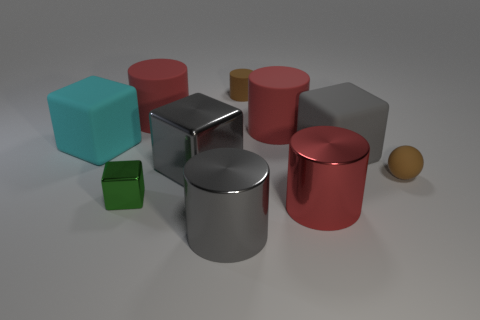How many objects are the same shape? Within the image, there are several objects sharing identical shapes. For instance, there are two large cylinders and numerous cubes, each pair matching in shape.  Can you tell the relative sizes of these objects? The objects vary in size, with some shapes like the cubes being present in at least two distinct sizes. The cylinders also come in different sizes, as do the spherical shapes, which are the smallest objects in the scene. 